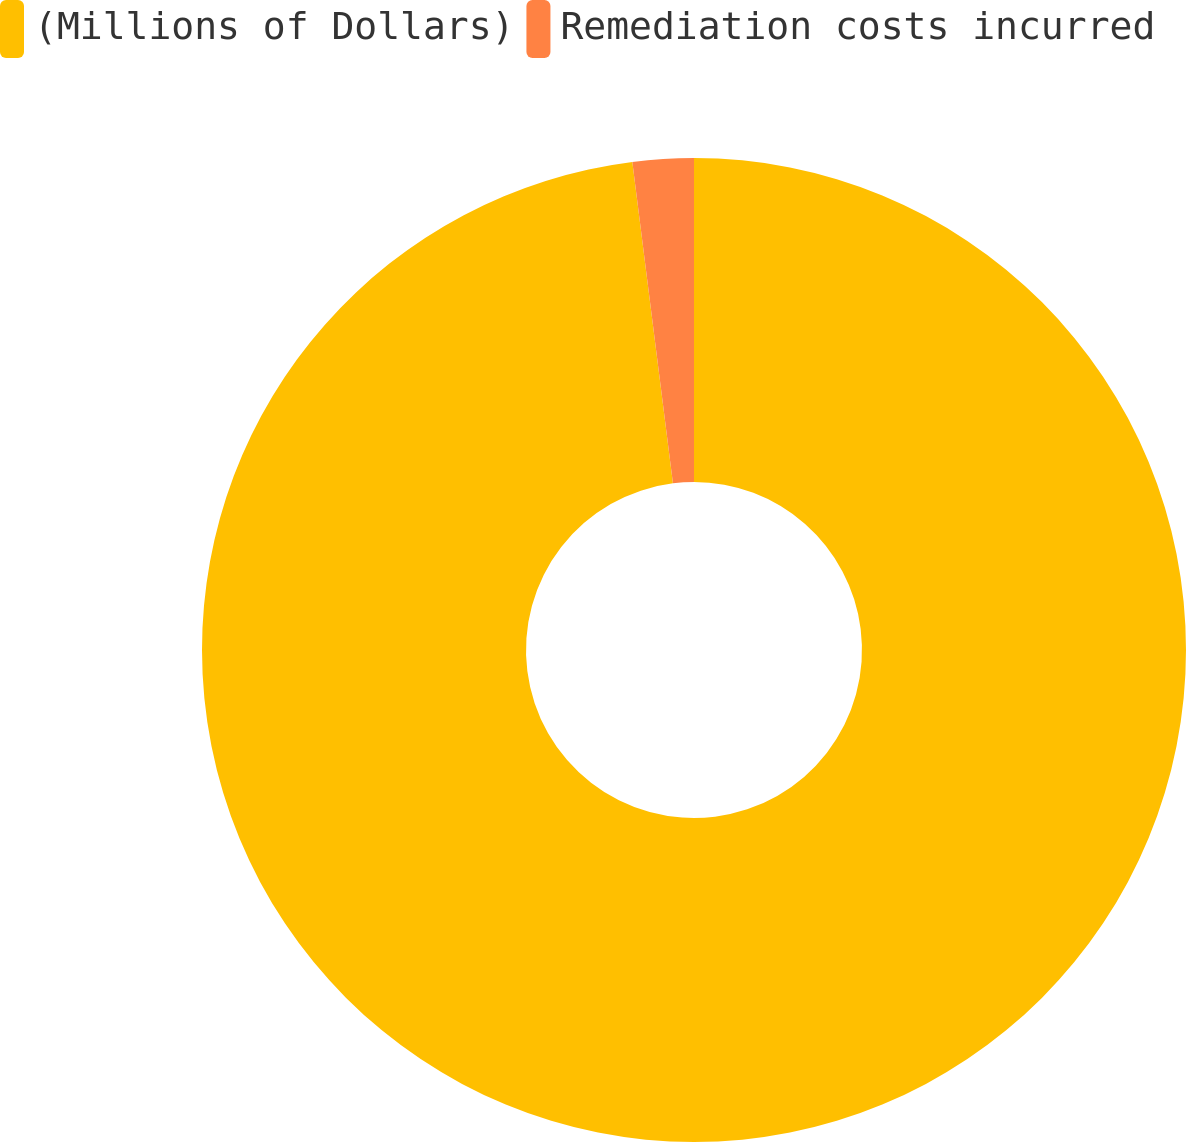Convert chart. <chart><loc_0><loc_0><loc_500><loc_500><pie_chart><fcel>(Millions of Dollars)<fcel>Remediation costs incurred<nl><fcel>98.0%<fcel>2.0%<nl></chart> 